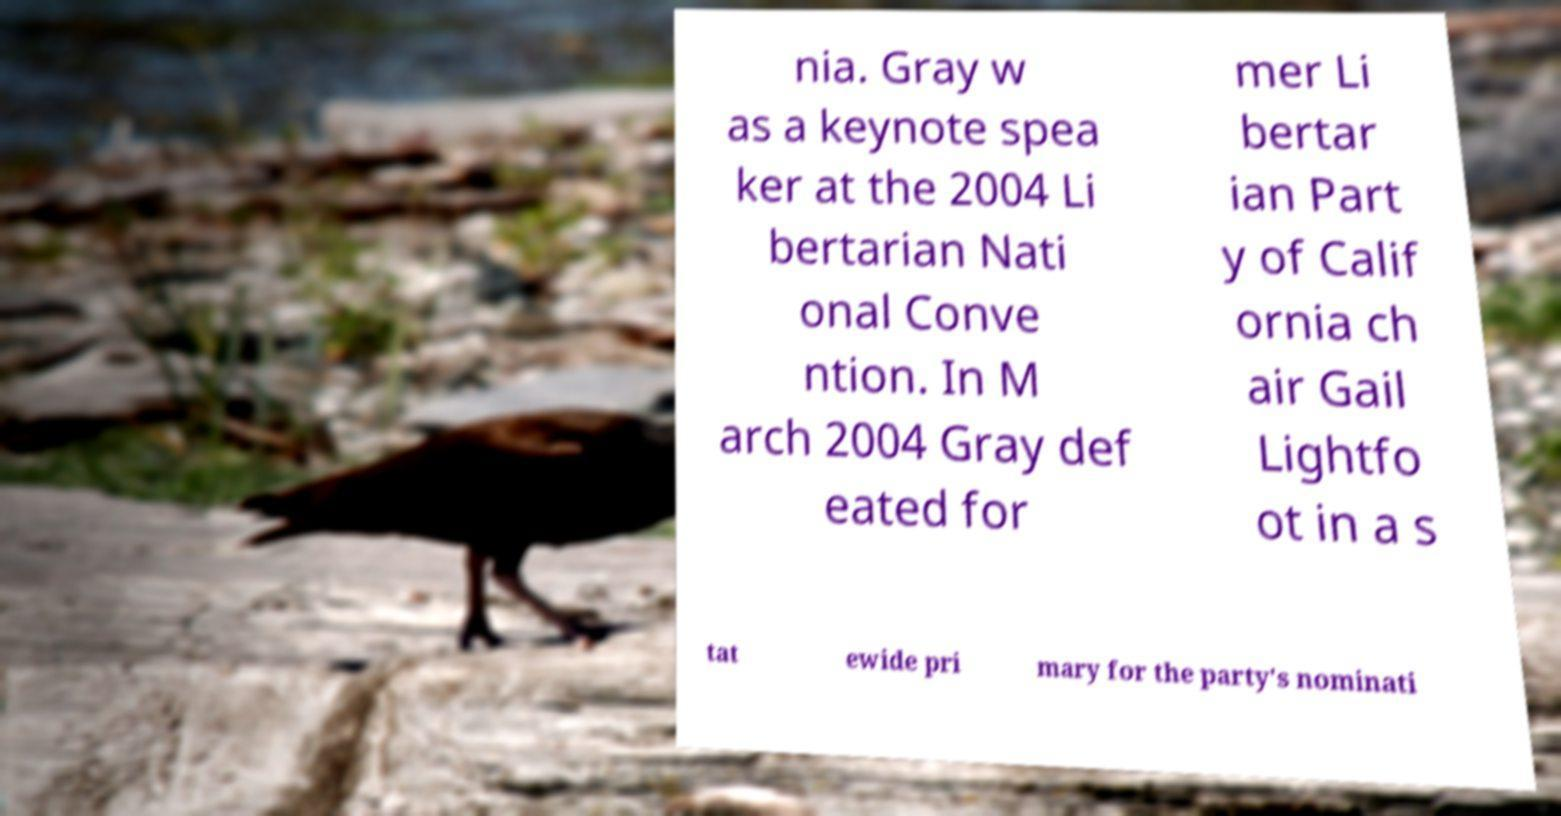I need the written content from this picture converted into text. Can you do that? nia. Gray w as a keynote spea ker at the 2004 Li bertarian Nati onal Conve ntion. In M arch 2004 Gray def eated for mer Li bertar ian Part y of Calif ornia ch air Gail Lightfo ot in a s tat ewide pri mary for the party's nominati 